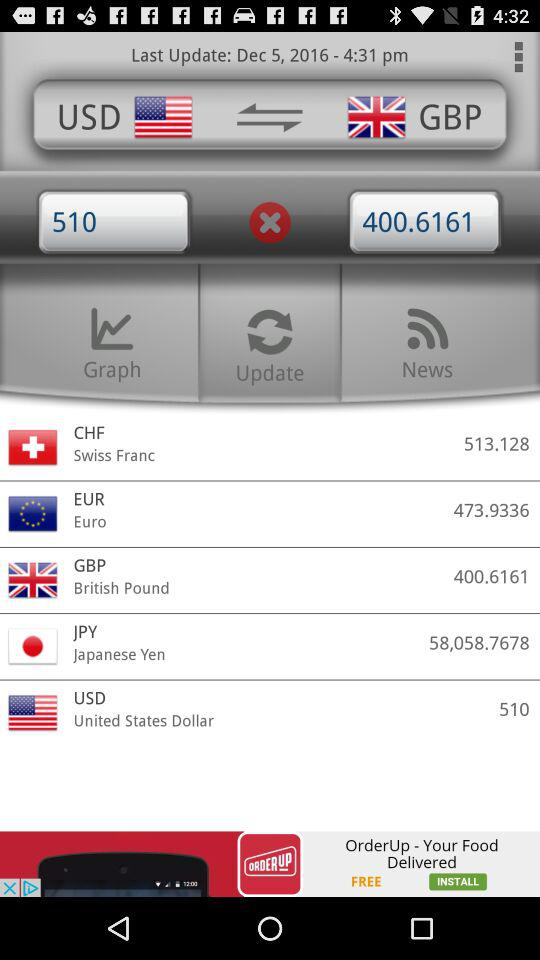When was the page last updated? The page was last updated at 4:31 p.m. on December 5, 2016. 